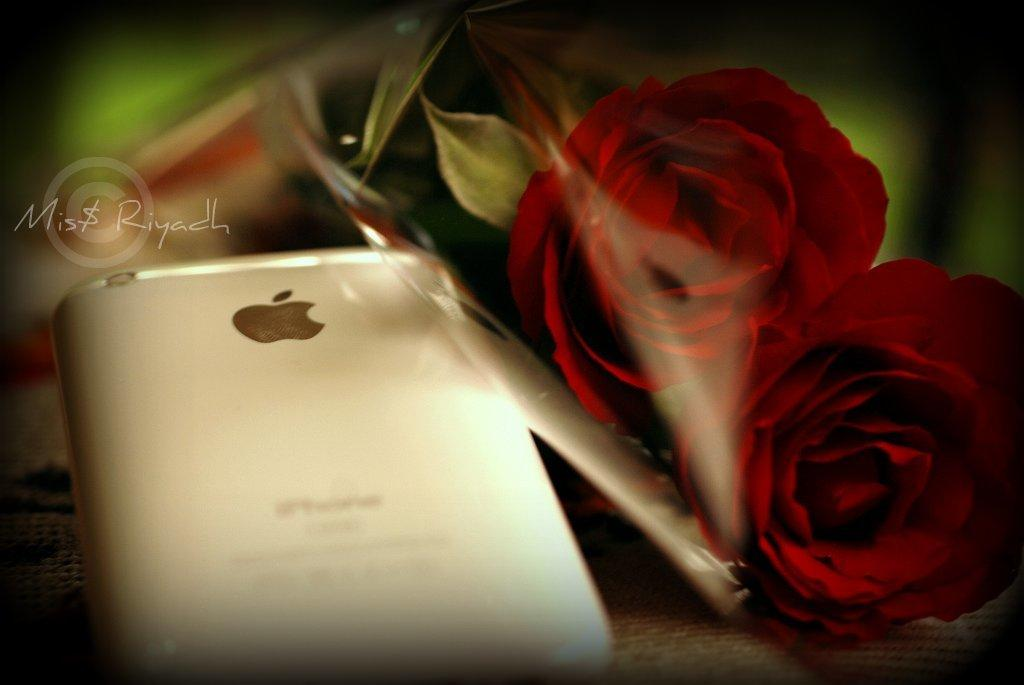What type of image is being described? The image is an edited image. What is present on the table in the image? There is a mobile phone and a bouquet with beautiful roses on the table. Can you describe the bouquet in more detail? The bouquet consists of beautiful roses. Where is the map located in the image? There is no map present in the image. What type of porter is carrying the mobile phone in the image? There is no porter present in the image, and the mobile phone is on the table. What type of tank can be seen in the background of the image? There is no tank present in the image. 